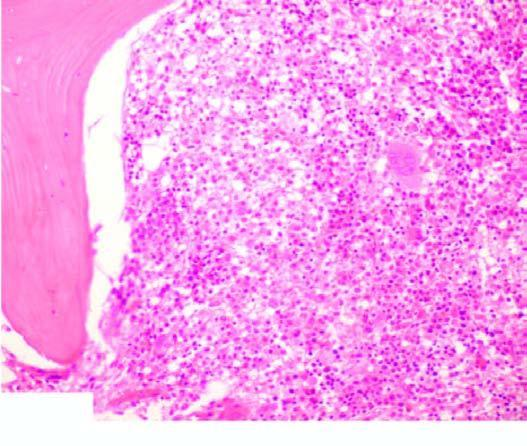does lassification of chromosomes show replacement of marrow spaces with abnormal mononuclear cells?
Answer the question using a single word or phrase. No 